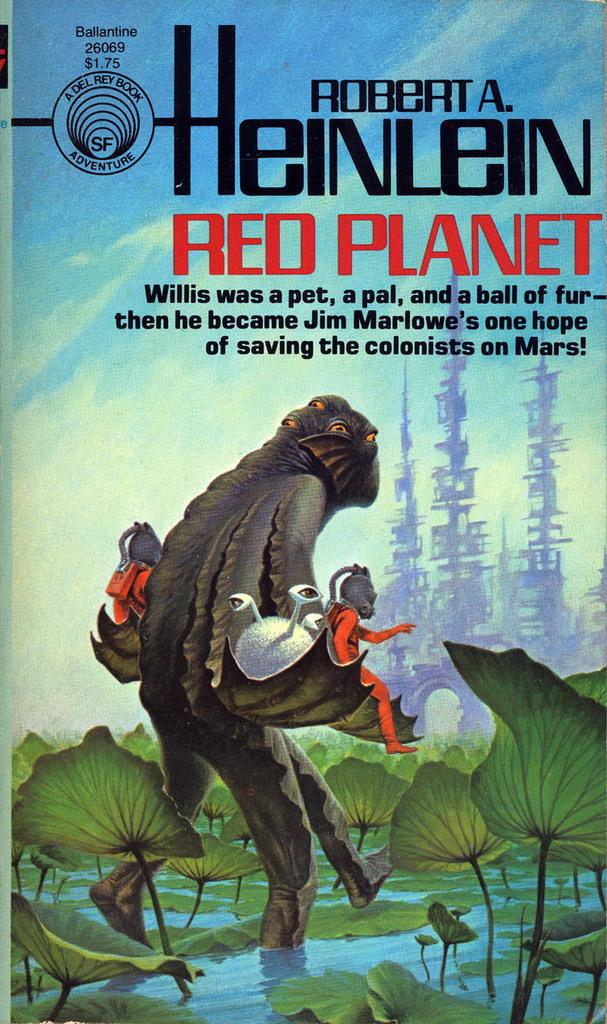What can be seen in the image that resembles illustrations or artwork? There are drawings in the image. What type of natural elements are present in the image? There are leaves in the image. What type of written content can be seen in the image? There is text written on the image. How many beds are visible in the image? There are no beds present in the image. What type of work is being done in the image? There is no work being done in the image; it features drawings, leaves, and text. 